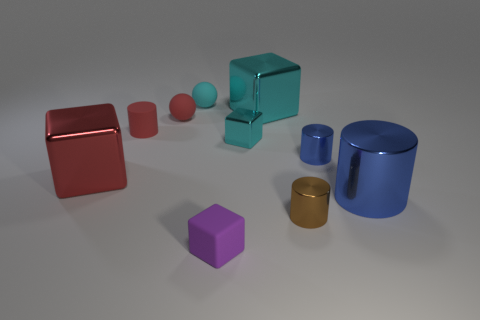Subtract all large shiny cylinders. How many cylinders are left? 3 Subtract 2 balls. How many balls are left? 0 Subtract all cyan blocks. How many blocks are left? 2 Subtract all cyan cubes. How many brown cylinders are left? 1 Subtract all spheres. How many objects are left? 8 Subtract all brown balls. Subtract all gray blocks. How many balls are left? 2 Subtract all green rubber cubes. Subtract all tiny blocks. How many objects are left? 8 Add 8 small cyan matte spheres. How many small cyan matte spheres are left? 9 Add 9 brown metal cylinders. How many brown metal cylinders exist? 10 Subtract 0 brown spheres. How many objects are left? 10 